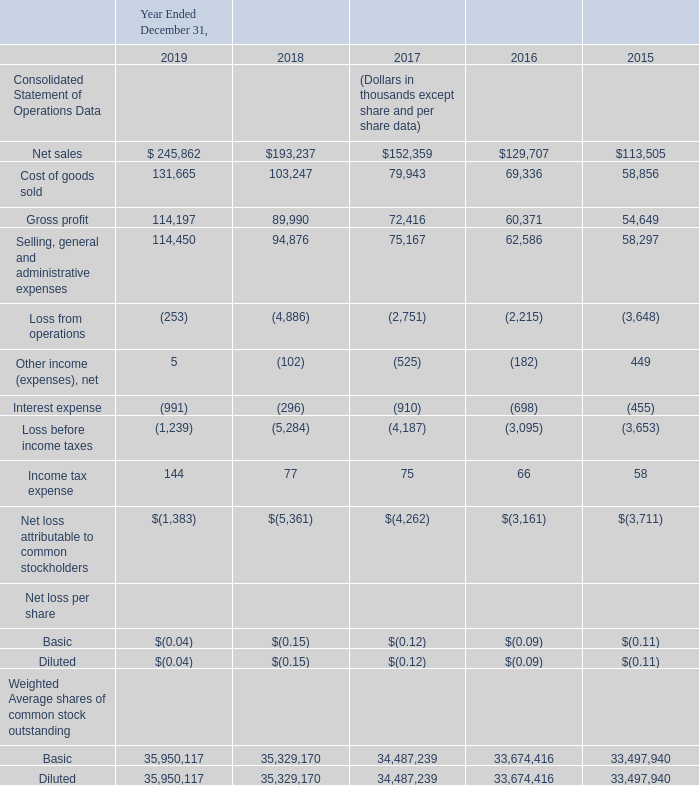ITEM 6. SELECTED FINANCIAL DATA
The following selected consolidated financial data should be read together with our consolidated financial statements and accompanying notes and “Management’s Discussion and Analysis of Financial Condition and Results of Operations” appearing elsewhere in this report. The selected consolidated financial data in this section is not intended to replace our consolidated financial statements and the accompanying notes. Our historical results are not necessarily indicative of our future results.
We derived the consolidated statements of operations data for the fiscal years ended December 31, 2019, 2018 and 2017 and the consolidated balance sheets data as of December 31, 2019 and 2018 from our audited consolidated financial statements appearing elsewhere in this report. The consolidated statement of operations data for the years ended December 31, 2016 and 2015 and the consolidated balance sheet data as of December 31, 2017, 2016 and 2015 have been derived from our audited consolidated financial statements, which are not included in this report.
Which financial years' information is shown in the table? 2015, 2016, 2017, 2018, 2019. What are the 2 types of shares seen in the table? Basic, diluted. What is the net loss per basic share as at each financial year end between 2015-2019 respectively? $(0.11), $(0.09), $(0.12), $(0.15), $(0.04). What is the percentage change in net sales from 2018 to 2019?
Answer scale should be: percent. (245,862-193,237)/193,237
Answer: 27.23. What is the percentage change in cost of goods sold from 2018 to 2019?
Answer scale should be: percent. (131,665-103,247)/103,247
Answer: 27.52. What is the percentage change in gross profit from 2018 to 2019 year end?
Answer scale should be: percent. (114,197-89,990)/89,990
Answer: 26.9. 